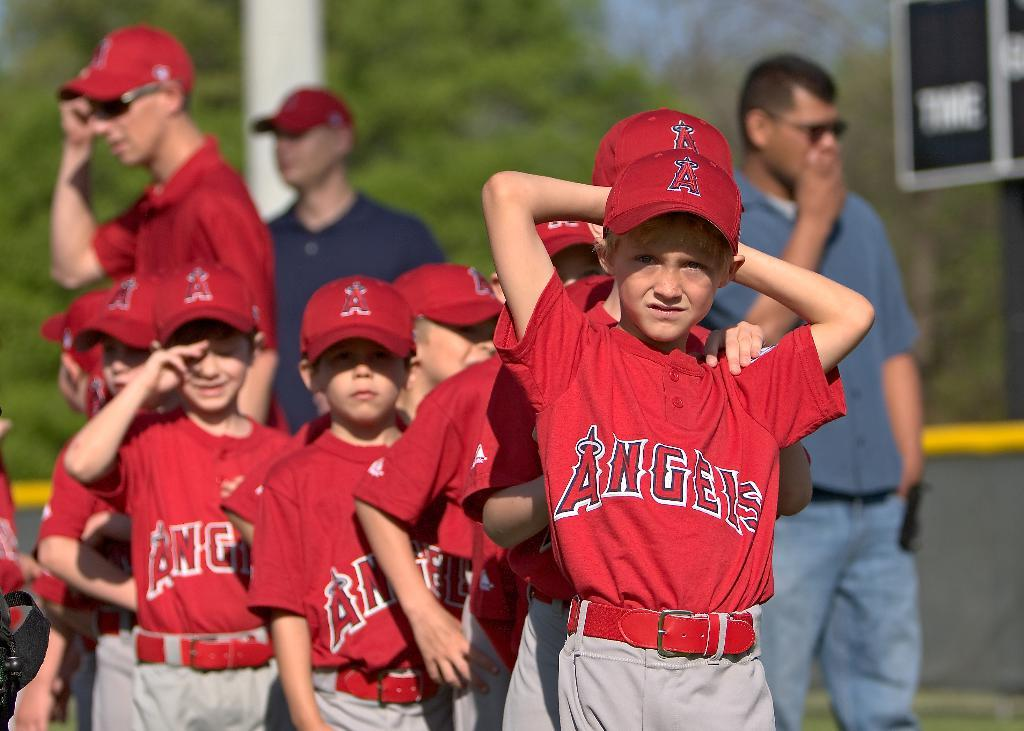<image>
Summarize the visual content of the image. Baseball players from the Angels posing for the camera 